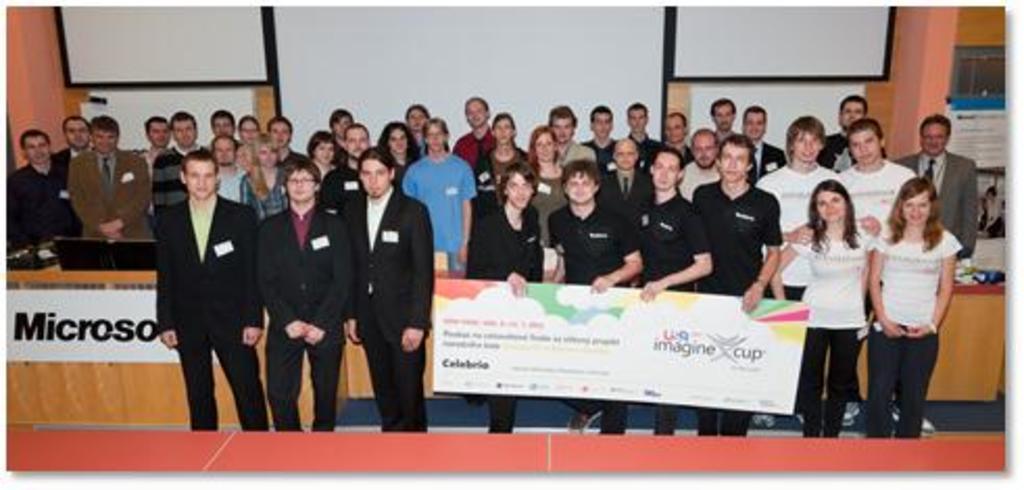Describe this image in one or two sentences. There is an image of people standing. People at the front are holding a board. There are white boards at the back. There are monitors on the left. 